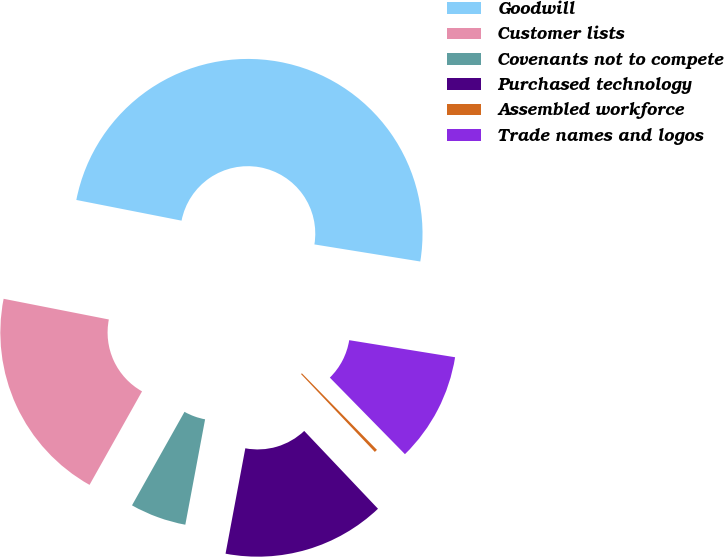Convert chart to OTSL. <chart><loc_0><loc_0><loc_500><loc_500><pie_chart><fcel>Goodwill<fcel>Customer lists<fcel>Covenants not to compete<fcel>Purchased technology<fcel>Assembled workforce<fcel>Trade names and logos<nl><fcel>49.46%<fcel>19.95%<fcel>5.19%<fcel>15.03%<fcel>0.27%<fcel>10.11%<nl></chart> 